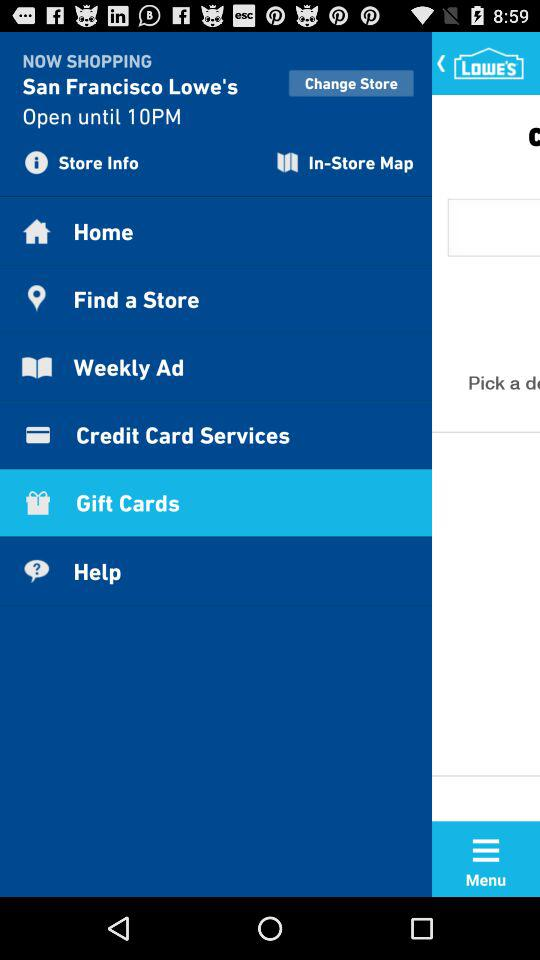What's the closing time of the store? The closing time is 10 PM. 